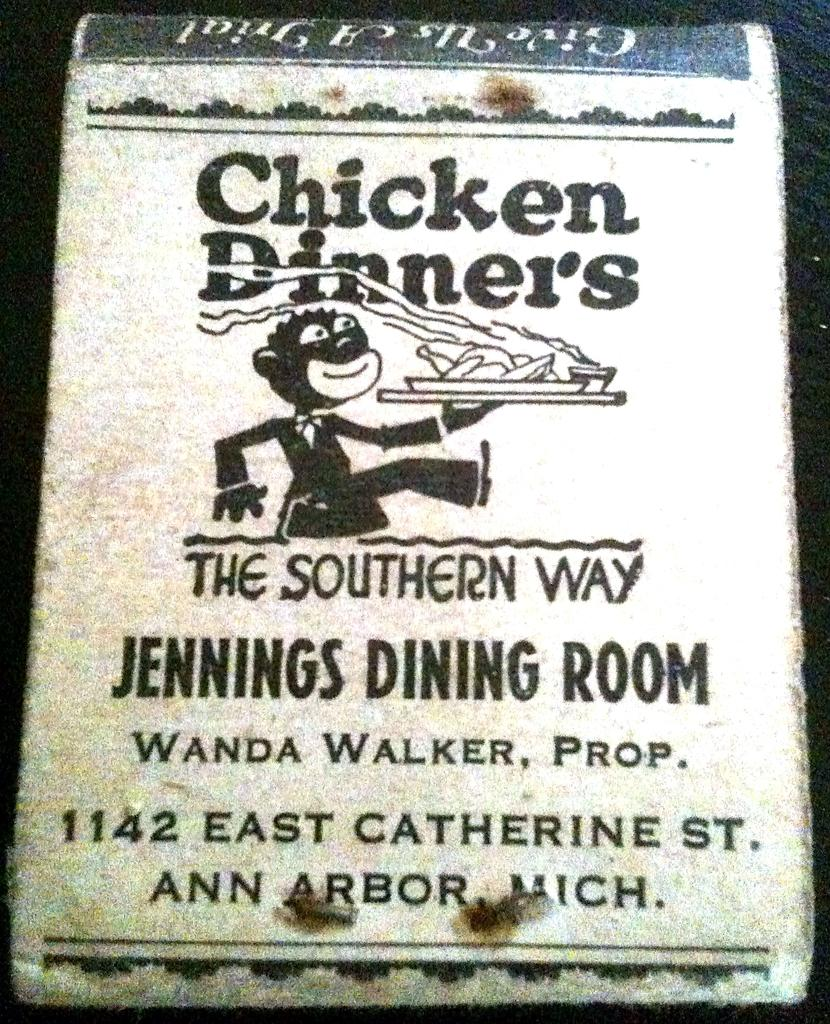<image>
Summarize the visual content of the image. A Chicken Dinners pamphlet from Ann Arbor, Mich. 